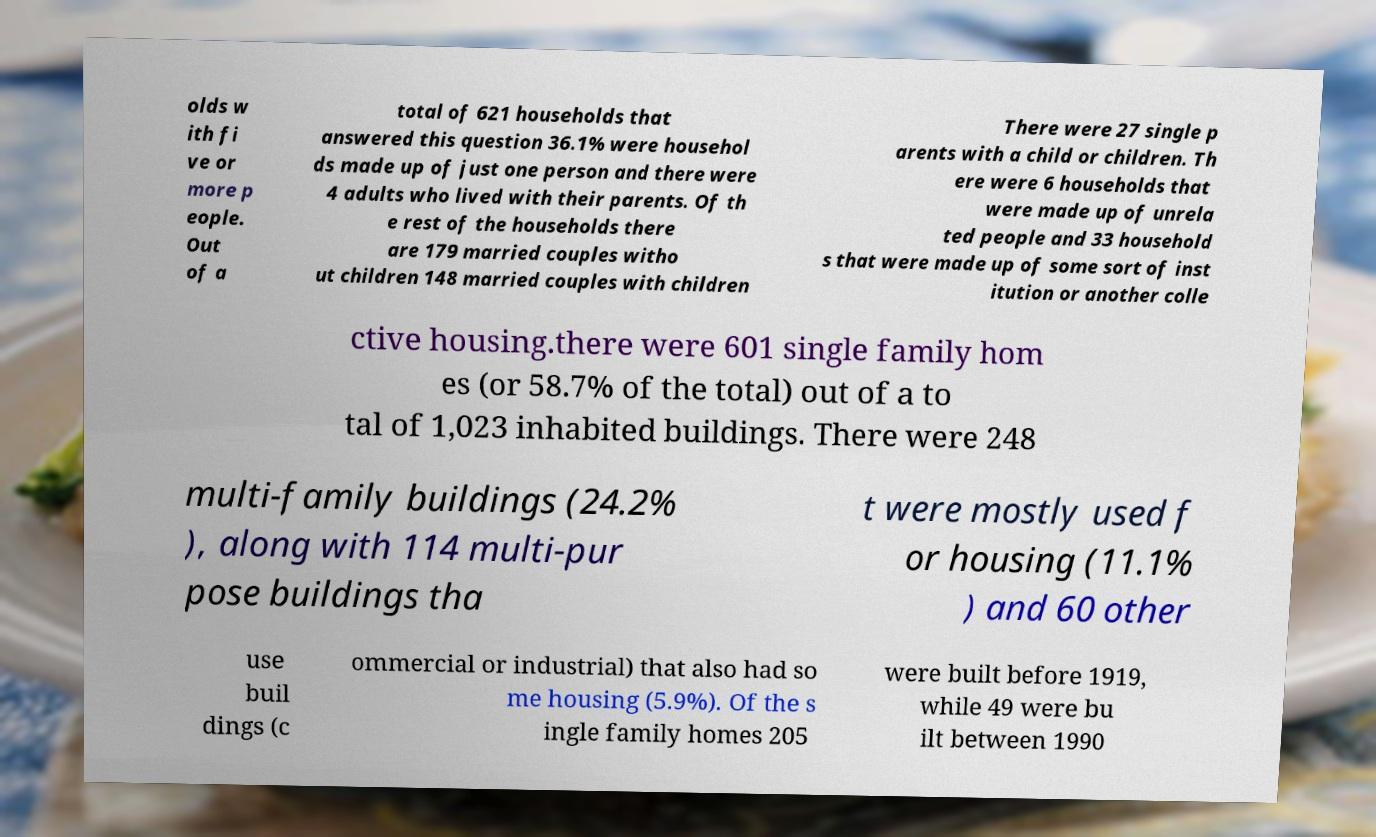Could you assist in decoding the text presented in this image and type it out clearly? olds w ith fi ve or more p eople. Out of a total of 621 households that answered this question 36.1% were househol ds made up of just one person and there were 4 adults who lived with their parents. Of th e rest of the households there are 179 married couples witho ut children 148 married couples with children There were 27 single p arents with a child or children. Th ere were 6 households that were made up of unrela ted people and 33 household s that were made up of some sort of inst itution or another colle ctive housing.there were 601 single family hom es (or 58.7% of the total) out of a to tal of 1,023 inhabited buildings. There were 248 multi-family buildings (24.2% ), along with 114 multi-pur pose buildings tha t were mostly used f or housing (11.1% ) and 60 other use buil dings (c ommercial or industrial) that also had so me housing (5.9%). Of the s ingle family homes 205 were built before 1919, while 49 were bu ilt between 1990 